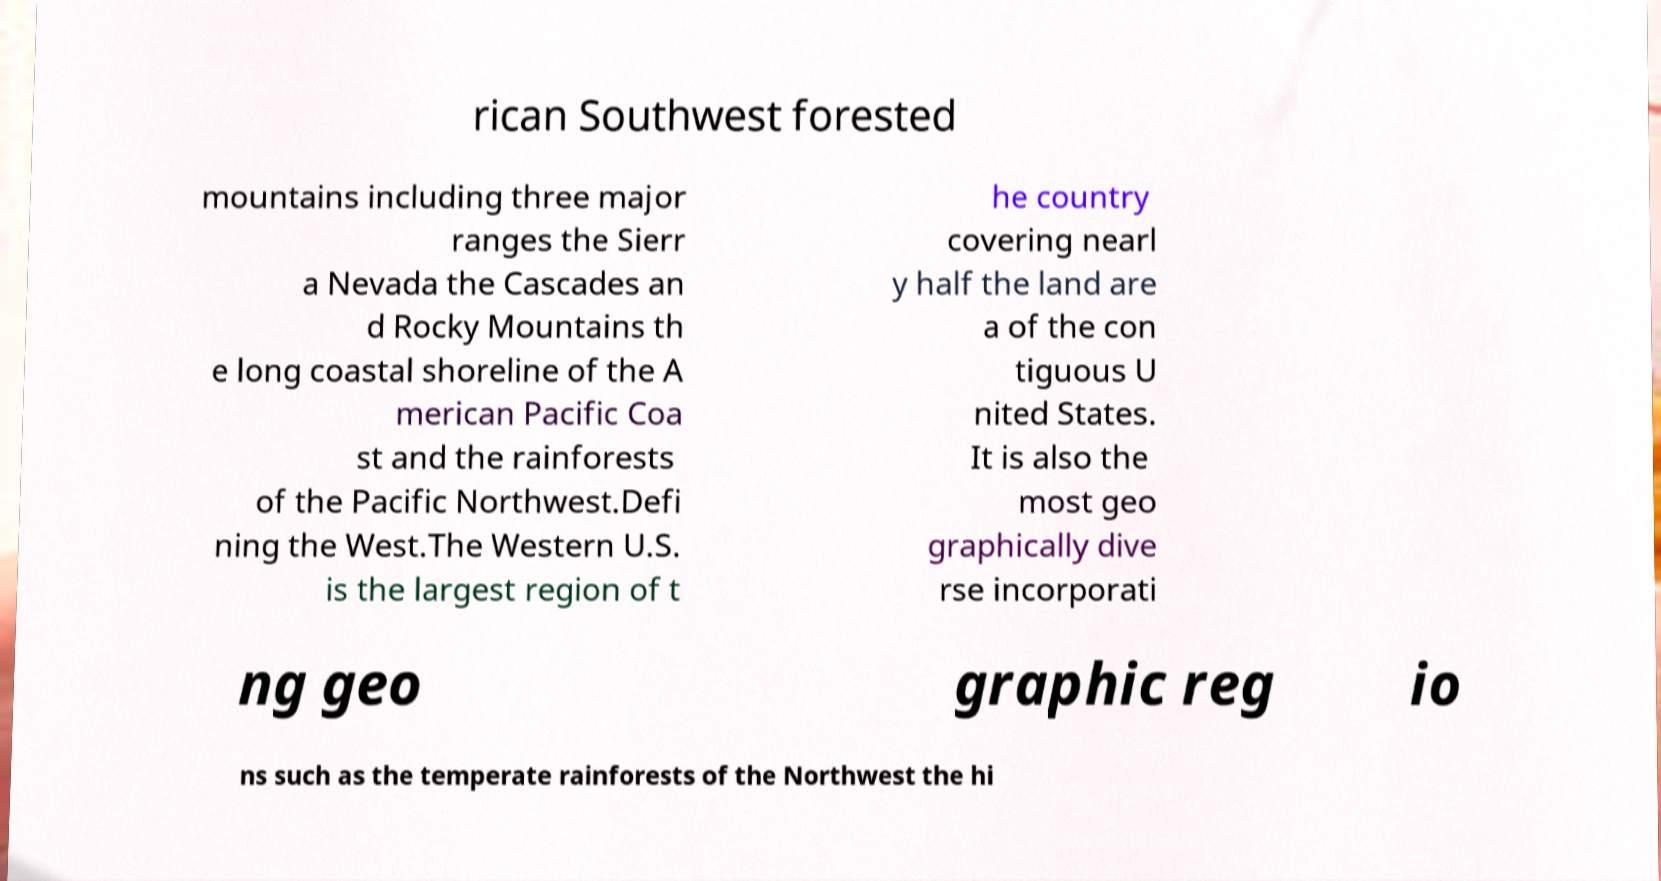Can you read and provide the text displayed in the image?This photo seems to have some interesting text. Can you extract and type it out for me? rican Southwest forested mountains including three major ranges the Sierr a Nevada the Cascades an d Rocky Mountains th e long coastal shoreline of the A merican Pacific Coa st and the rainforests of the Pacific Northwest.Defi ning the West.The Western U.S. is the largest region of t he country covering nearl y half the land are a of the con tiguous U nited States. It is also the most geo graphically dive rse incorporati ng geo graphic reg io ns such as the temperate rainforests of the Northwest the hi 